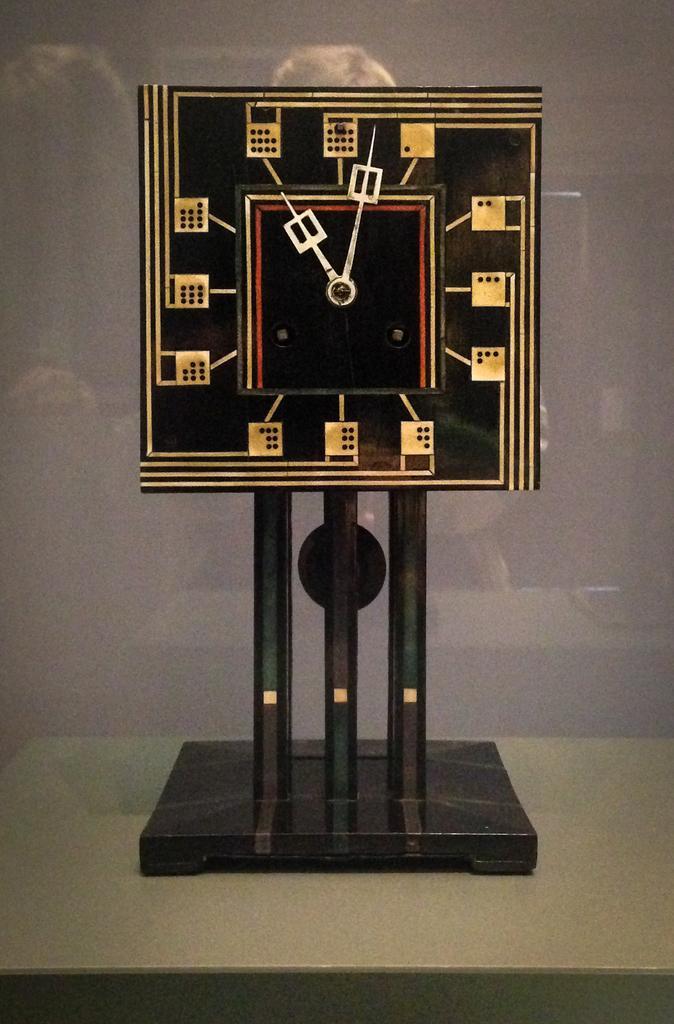Could you give a brief overview of what you see in this image? In this image there is a Charles Rennie Mackintosh clock. 